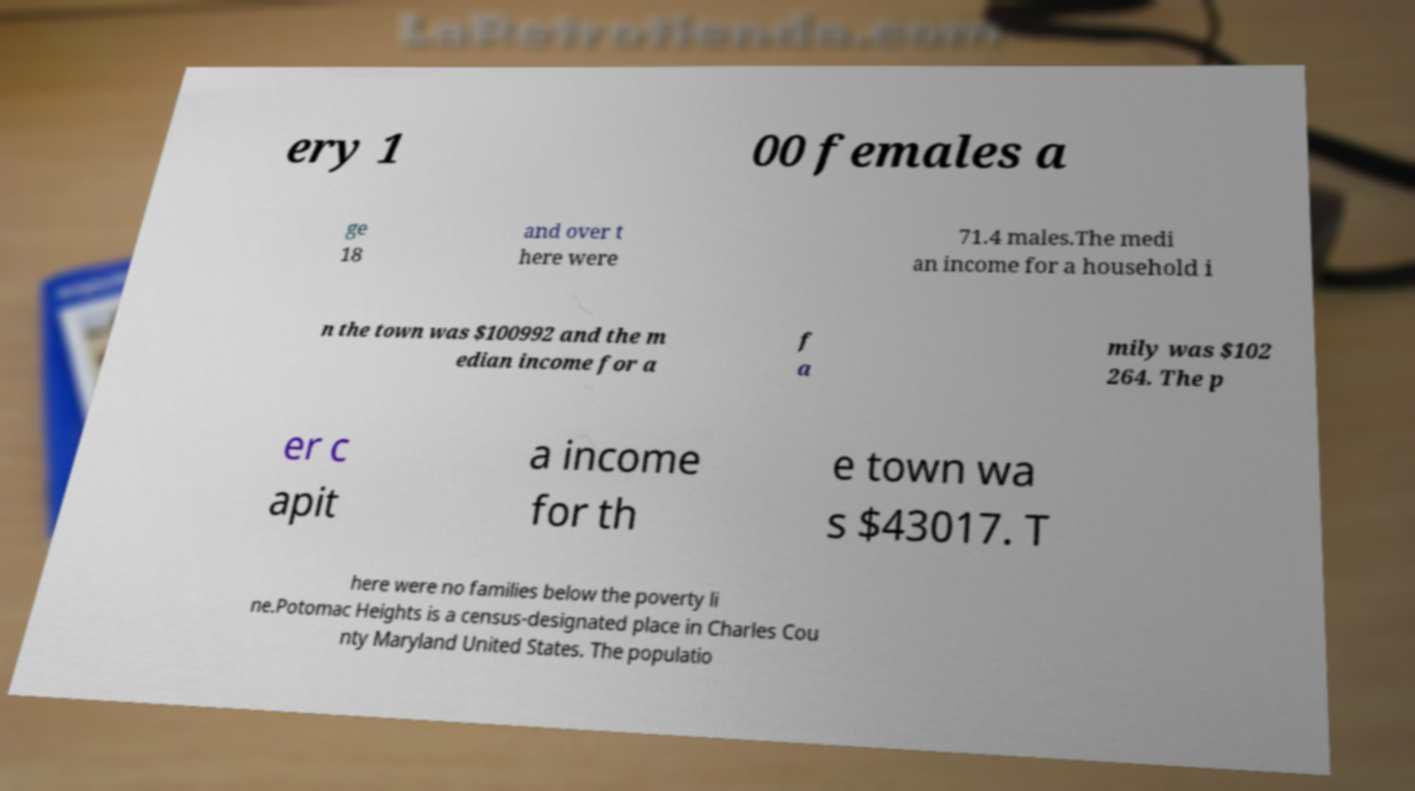Can you read and provide the text displayed in the image?This photo seems to have some interesting text. Can you extract and type it out for me? ery 1 00 females a ge 18 and over t here were 71.4 males.The medi an income for a household i n the town was $100992 and the m edian income for a f a mily was $102 264. The p er c apit a income for th e town wa s $43017. T here were no families below the poverty li ne.Potomac Heights is a census-designated place in Charles Cou nty Maryland United States. The populatio 